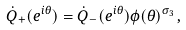<formula> <loc_0><loc_0><loc_500><loc_500>\dot { Q } _ { + } ( e ^ { i \theta } ) = \dot { Q } _ { - } ( e ^ { i \theta } ) \phi ( \theta ) ^ { \sigma _ { 3 } } \, ,</formula> 